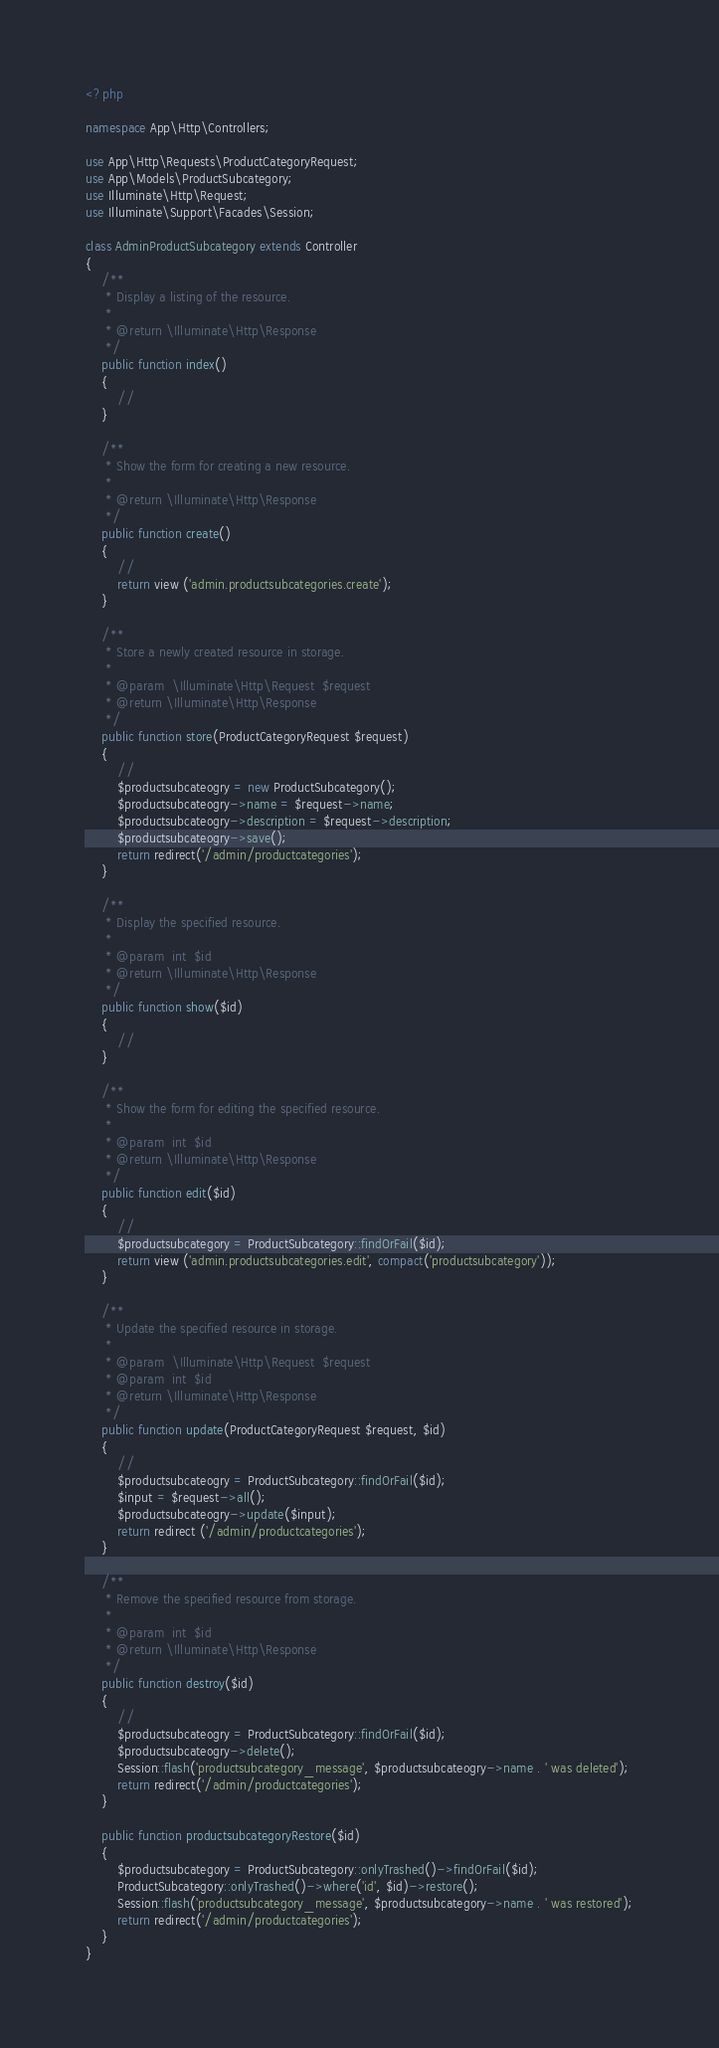<code> <loc_0><loc_0><loc_500><loc_500><_PHP_><?php

namespace App\Http\Controllers;

use App\Http\Requests\ProductCategoryRequest;
use App\Models\ProductSubcategory;
use Illuminate\Http\Request;
use Illuminate\Support\Facades\Session;

class AdminProductSubcategory extends Controller
{
    /**
     * Display a listing of the resource.
     *
     * @return \Illuminate\Http\Response
     */
    public function index()
    {
        //
    }

    /**
     * Show the form for creating a new resource.
     *
     * @return \Illuminate\Http\Response
     */
    public function create()
    {
        //
        return view ('admin.productsubcategories.create');
    }

    /**
     * Store a newly created resource in storage.
     *
     * @param  \Illuminate\Http\Request  $request
     * @return \Illuminate\Http\Response
     */
    public function store(ProductCategoryRequest $request)
    {
        //
        $productsubcateogry = new ProductSubcategory();
        $productsubcateogry->name = $request->name;
        $productsubcateogry->description = $request->description;
        $productsubcateogry->save();
        return redirect('/admin/productcategories');
    }

    /**
     * Display the specified resource.
     *
     * @param  int  $id
     * @return \Illuminate\Http\Response
     */
    public function show($id)
    {
        //
    }

    /**
     * Show the form for editing the specified resource.
     *
     * @param  int  $id
     * @return \Illuminate\Http\Response
     */
    public function edit($id)
    {
        //
        $productsubcategory = ProductSubcategory::findOrFail($id);
        return view ('admin.productsubcategories.edit', compact('productsubcategory'));
    }

    /**
     * Update the specified resource in storage.
     *
     * @param  \Illuminate\Http\Request  $request
     * @param  int  $id
     * @return \Illuminate\Http\Response
     */
    public function update(ProductCategoryRequest $request, $id)
    {
        //
        $productsubcateogry = ProductSubcategory::findOrFail($id);
        $input = $request->all();
        $productsubcateogry->update($input);
        return redirect ('/admin/productcategories');
    }

    /**
     * Remove the specified resource from storage.
     *
     * @param  int  $id
     * @return \Illuminate\Http\Response
     */
    public function destroy($id)
    {
        //
        $productsubcateogry = ProductSubcategory::findOrFail($id);
        $productsubcateogry->delete();
        Session::flash('productsubcategory_message', $productsubcateogry->name . ' was deleted');
        return redirect('/admin/productcategories');
    }

    public function productsubcategoryRestore($id)
    {
        $productsubcategory = ProductSubcategory::onlyTrashed()->findOrFail($id);
        ProductSubcategory::onlyTrashed()->where('id', $id)->restore();
        Session::flash('productsubcategory_message', $productsubcategory->name . ' was restored');
        return redirect('/admin/productcategories');
    }
}
</code> 